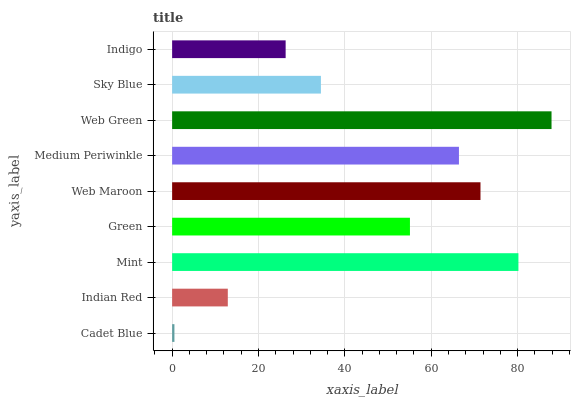Is Cadet Blue the minimum?
Answer yes or no. Yes. Is Web Green the maximum?
Answer yes or no. Yes. Is Indian Red the minimum?
Answer yes or no. No. Is Indian Red the maximum?
Answer yes or no. No. Is Indian Red greater than Cadet Blue?
Answer yes or no. Yes. Is Cadet Blue less than Indian Red?
Answer yes or no. Yes. Is Cadet Blue greater than Indian Red?
Answer yes or no. No. Is Indian Red less than Cadet Blue?
Answer yes or no. No. Is Green the high median?
Answer yes or no. Yes. Is Green the low median?
Answer yes or no. Yes. Is Web Green the high median?
Answer yes or no. No. Is Indian Red the low median?
Answer yes or no. No. 